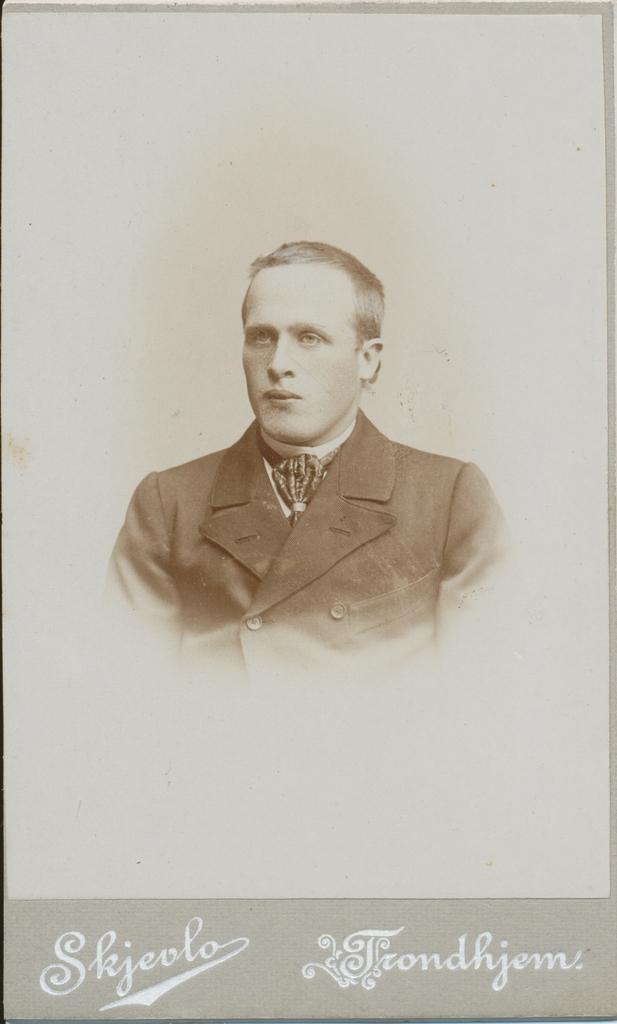In one or two sentences, can you explain what this image depicts? There is a poster having image of a person and there are texts on this poster. And the background of this poster is gray in color. 